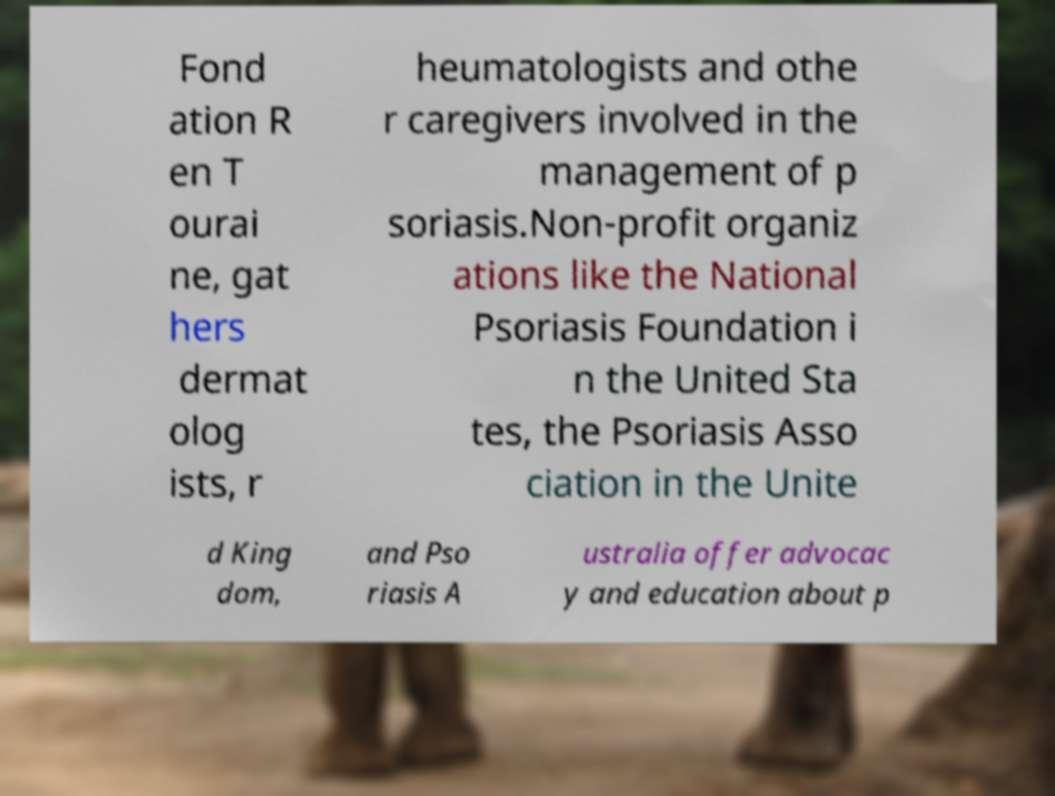Can you accurately transcribe the text from the provided image for me? Fond ation R en T ourai ne, gat hers dermat olog ists, r heumatologists and othe r caregivers involved in the management of p soriasis.Non-profit organiz ations like the National Psoriasis Foundation i n the United Sta tes, the Psoriasis Asso ciation in the Unite d King dom, and Pso riasis A ustralia offer advocac y and education about p 